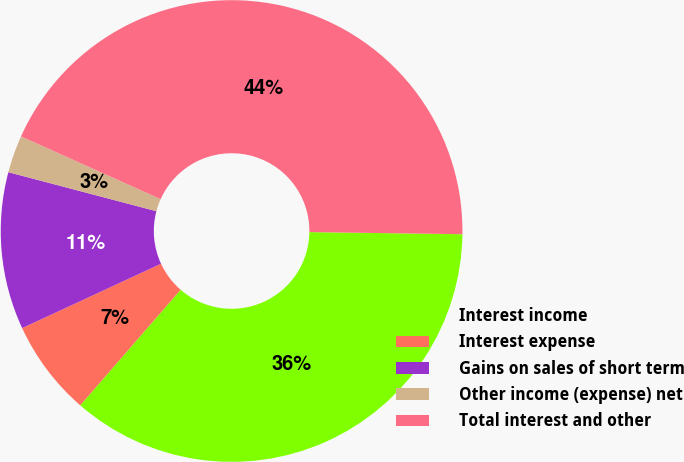Convert chart to OTSL. <chart><loc_0><loc_0><loc_500><loc_500><pie_chart><fcel>Interest income<fcel>Interest expense<fcel>Gains on sales of short term<fcel>Other income (expense) net<fcel>Total interest and other<nl><fcel>36.16%<fcel>6.71%<fcel>11.01%<fcel>2.62%<fcel>43.5%<nl></chart> 